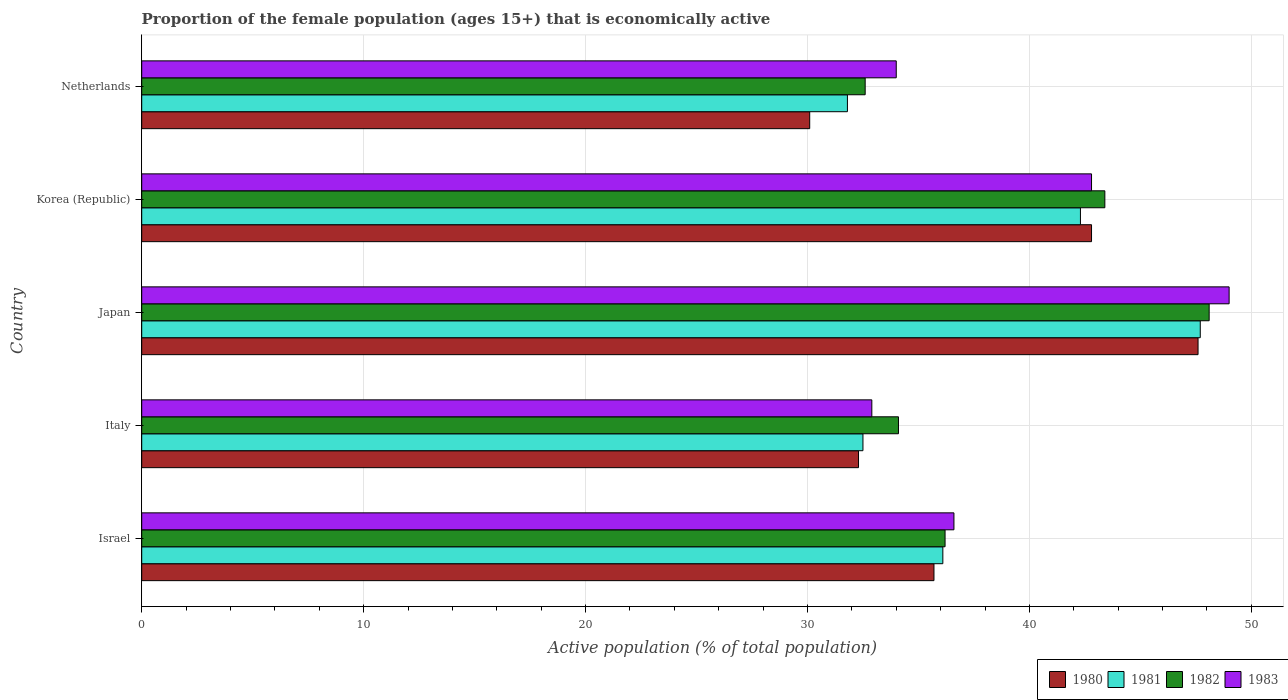How many groups of bars are there?
Make the answer very short. 5. Are the number of bars on each tick of the Y-axis equal?
Give a very brief answer. Yes. How many bars are there on the 5th tick from the top?
Provide a short and direct response. 4. What is the label of the 1st group of bars from the top?
Your answer should be compact. Netherlands. In how many cases, is the number of bars for a given country not equal to the number of legend labels?
Your answer should be very brief. 0. What is the proportion of the female population that is economically active in 1983 in Korea (Republic)?
Give a very brief answer. 42.8. Across all countries, what is the minimum proportion of the female population that is economically active in 1980?
Your answer should be very brief. 30.1. In which country was the proportion of the female population that is economically active in 1983 minimum?
Your response must be concise. Italy. What is the total proportion of the female population that is economically active in 1980 in the graph?
Offer a terse response. 188.5. What is the difference between the proportion of the female population that is economically active in 1983 in Korea (Republic) and that in Netherlands?
Offer a very short reply. 8.8. What is the average proportion of the female population that is economically active in 1980 per country?
Provide a succinct answer. 37.7. What is the difference between the proportion of the female population that is economically active in 1982 and proportion of the female population that is economically active in 1981 in Korea (Republic)?
Offer a terse response. 1.1. What is the ratio of the proportion of the female population that is economically active in 1982 in Italy to that in Netherlands?
Provide a succinct answer. 1.05. What is the difference between the highest and the second highest proportion of the female population that is economically active in 1980?
Your answer should be very brief. 4.8. What is the difference between the highest and the lowest proportion of the female population that is economically active in 1983?
Your response must be concise. 16.1. In how many countries, is the proportion of the female population that is economically active in 1982 greater than the average proportion of the female population that is economically active in 1982 taken over all countries?
Your answer should be compact. 2. What does the 3rd bar from the bottom in Italy represents?
Your response must be concise. 1982. Is it the case that in every country, the sum of the proportion of the female population that is economically active in 1980 and proportion of the female population that is economically active in 1981 is greater than the proportion of the female population that is economically active in 1982?
Your answer should be compact. Yes. Are all the bars in the graph horizontal?
Offer a terse response. Yes. How many countries are there in the graph?
Offer a terse response. 5. What is the difference between two consecutive major ticks on the X-axis?
Your response must be concise. 10. Are the values on the major ticks of X-axis written in scientific E-notation?
Your response must be concise. No. Does the graph contain any zero values?
Your answer should be very brief. No. Does the graph contain grids?
Give a very brief answer. Yes. How many legend labels are there?
Give a very brief answer. 4. How are the legend labels stacked?
Give a very brief answer. Horizontal. What is the title of the graph?
Your response must be concise. Proportion of the female population (ages 15+) that is economically active. Does "1993" appear as one of the legend labels in the graph?
Provide a short and direct response. No. What is the label or title of the X-axis?
Offer a terse response. Active population (% of total population). What is the label or title of the Y-axis?
Your response must be concise. Country. What is the Active population (% of total population) in 1980 in Israel?
Provide a succinct answer. 35.7. What is the Active population (% of total population) of 1981 in Israel?
Offer a very short reply. 36.1. What is the Active population (% of total population) of 1982 in Israel?
Your response must be concise. 36.2. What is the Active population (% of total population) in 1983 in Israel?
Your answer should be very brief. 36.6. What is the Active population (% of total population) in 1980 in Italy?
Keep it short and to the point. 32.3. What is the Active population (% of total population) of 1981 in Italy?
Provide a succinct answer. 32.5. What is the Active population (% of total population) of 1982 in Italy?
Your answer should be very brief. 34.1. What is the Active population (% of total population) of 1983 in Italy?
Your answer should be very brief. 32.9. What is the Active population (% of total population) of 1980 in Japan?
Your answer should be very brief. 47.6. What is the Active population (% of total population) of 1981 in Japan?
Offer a very short reply. 47.7. What is the Active population (% of total population) of 1982 in Japan?
Your answer should be very brief. 48.1. What is the Active population (% of total population) in 1980 in Korea (Republic)?
Give a very brief answer. 42.8. What is the Active population (% of total population) of 1981 in Korea (Republic)?
Provide a succinct answer. 42.3. What is the Active population (% of total population) of 1982 in Korea (Republic)?
Offer a very short reply. 43.4. What is the Active population (% of total population) in 1983 in Korea (Republic)?
Your answer should be compact. 42.8. What is the Active population (% of total population) of 1980 in Netherlands?
Make the answer very short. 30.1. What is the Active population (% of total population) of 1981 in Netherlands?
Provide a short and direct response. 31.8. What is the Active population (% of total population) in 1982 in Netherlands?
Give a very brief answer. 32.6. What is the Active population (% of total population) in 1983 in Netherlands?
Your answer should be very brief. 34. Across all countries, what is the maximum Active population (% of total population) in 1980?
Offer a very short reply. 47.6. Across all countries, what is the maximum Active population (% of total population) of 1981?
Give a very brief answer. 47.7. Across all countries, what is the maximum Active population (% of total population) of 1982?
Make the answer very short. 48.1. Across all countries, what is the maximum Active population (% of total population) of 1983?
Make the answer very short. 49. Across all countries, what is the minimum Active population (% of total population) in 1980?
Keep it short and to the point. 30.1. Across all countries, what is the minimum Active population (% of total population) in 1981?
Your response must be concise. 31.8. Across all countries, what is the minimum Active population (% of total population) of 1982?
Your answer should be very brief. 32.6. Across all countries, what is the minimum Active population (% of total population) of 1983?
Offer a very short reply. 32.9. What is the total Active population (% of total population) of 1980 in the graph?
Your answer should be very brief. 188.5. What is the total Active population (% of total population) of 1981 in the graph?
Ensure brevity in your answer.  190.4. What is the total Active population (% of total population) in 1982 in the graph?
Provide a short and direct response. 194.4. What is the total Active population (% of total population) of 1983 in the graph?
Provide a succinct answer. 195.3. What is the difference between the Active population (% of total population) in 1981 in Israel and that in Italy?
Your answer should be compact. 3.6. What is the difference between the Active population (% of total population) in 1982 in Israel and that in Italy?
Give a very brief answer. 2.1. What is the difference between the Active population (% of total population) in 1981 in Israel and that in Japan?
Offer a terse response. -11.6. What is the difference between the Active population (% of total population) of 1982 in Israel and that in Japan?
Ensure brevity in your answer.  -11.9. What is the difference between the Active population (% of total population) in 1980 in Israel and that in Korea (Republic)?
Offer a very short reply. -7.1. What is the difference between the Active population (% of total population) in 1980 in Israel and that in Netherlands?
Give a very brief answer. 5.6. What is the difference between the Active population (% of total population) of 1981 in Israel and that in Netherlands?
Your response must be concise. 4.3. What is the difference between the Active population (% of total population) in 1980 in Italy and that in Japan?
Provide a short and direct response. -15.3. What is the difference between the Active population (% of total population) of 1981 in Italy and that in Japan?
Your response must be concise. -15.2. What is the difference between the Active population (% of total population) in 1982 in Italy and that in Japan?
Your answer should be compact. -14. What is the difference between the Active population (% of total population) of 1983 in Italy and that in Japan?
Offer a terse response. -16.1. What is the difference between the Active population (% of total population) of 1981 in Italy and that in Korea (Republic)?
Offer a very short reply. -9.8. What is the difference between the Active population (% of total population) in 1980 in Italy and that in Netherlands?
Offer a very short reply. 2.2. What is the difference between the Active population (% of total population) of 1981 in Italy and that in Netherlands?
Offer a very short reply. 0.7. What is the difference between the Active population (% of total population) in 1982 in Italy and that in Netherlands?
Ensure brevity in your answer.  1.5. What is the difference between the Active population (% of total population) in 1983 in Italy and that in Netherlands?
Offer a very short reply. -1.1. What is the difference between the Active population (% of total population) in 1980 in Japan and that in Korea (Republic)?
Your response must be concise. 4.8. What is the difference between the Active population (% of total population) in 1981 in Japan and that in Korea (Republic)?
Your answer should be very brief. 5.4. What is the difference between the Active population (% of total population) in 1982 in Japan and that in Korea (Republic)?
Provide a succinct answer. 4.7. What is the difference between the Active population (% of total population) in 1983 in Japan and that in Korea (Republic)?
Give a very brief answer. 6.2. What is the difference between the Active population (% of total population) in 1980 in Japan and that in Netherlands?
Ensure brevity in your answer.  17.5. What is the difference between the Active population (% of total population) of 1981 in Japan and that in Netherlands?
Offer a very short reply. 15.9. What is the difference between the Active population (% of total population) of 1981 in Korea (Republic) and that in Netherlands?
Keep it short and to the point. 10.5. What is the difference between the Active population (% of total population) of 1983 in Korea (Republic) and that in Netherlands?
Provide a short and direct response. 8.8. What is the difference between the Active population (% of total population) in 1980 in Israel and the Active population (% of total population) in 1981 in Italy?
Your answer should be compact. 3.2. What is the difference between the Active population (% of total population) of 1980 in Israel and the Active population (% of total population) of 1982 in Italy?
Your answer should be compact. 1.6. What is the difference between the Active population (% of total population) in 1980 in Israel and the Active population (% of total population) in 1983 in Italy?
Give a very brief answer. 2.8. What is the difference between the Active population (% of total population) of 1981 in Israel and the Active population (% of total population) of 1982 in Italy?
Your answer should be compact. 2. What is the difference between the Active population (% of total population) of 1980 in Israel and the Active population (% of total population) of 1982 in Japan?
Your answer should be very brief. -12.4. What is the difference between the Active population (% of total population) in 1980 in Israel and the Active population (% of total population) in 1983 in Japan?
Your answer should be very brief. -13.3. What is the difference between the Active population (% of total population) of 1981 in Israel and the Active population (% of total population) of 1983 in Japan?
Your response must be concise. -12.9. What is the difference between the Active population (% of total population) in 1980 in Israel and the Active population (% of total population) in 1982 in Korea (Republic)?
Give a very brief answer. -7.7. What is the difference between the Active population (% of total population) of 1980 in Israel and the Active population (% of total population) of 1983 in Korea (Republic)?
Your response must be concise. -7.1. What is the difference between the Active population (% of total population) of 1981 in Israel and the Active population (% of total population) of 1982 in Korea (Republic)?
Provide a short and direct response. -7.3. What is the difference between the Active population (% of total population) in 1981 in Israel and the Active population (% of total population) in 1983 in Korea (Republic)?
Provide a succinct answer. -6.7. What is the difference between the Active population (% of total population) of 1980 in Israel and the Active population (% of total population) of 1981 in Netherlands?
Your answer should be compact. 3.9. What is the difference between the Active population (% of total population) in 1980 in Israel and the Active population (% of total population) in 1983 in Netherlands?
Make the answer very short. 1.7. What is the difference between the Active population (% of total population) of 1981 in Israel and the Active population (% of total population) of 1983 in Netherlands?
Offer a terse response. 2.1. What is the difference between the Active population (% of total population) of 1980 in Italy and the Active population (% of total population) of 1981 in Japan?
Ensure brevity in your answer.  -15.4. What is the difference between the Active population (% of total population) in 1980 in Italy and the Active population (% of total population) in 1982 in Japan?
Give a very brief answer. -15.8. What is the difference between the Active population (% of total population) in 1980 in Italy and the Active population (% of total population) in 1983 in Japan?
Offer a terse response. -16.7. What is the difference between the Active population (% of total population) in 1981 in Italy and the Active population (% of total population) in 1982 in Japan?
Give a very brief answer. -15.6. What is the difference between the Active population (% of total population) of 1981 in Italy and the Active population (% of total population) of 1983 in Japan?
Ensure brevity in your answer.  -16.5. What is the difference between the Active population (% of total population) in 1982 in Italy and the Active population (% of total population) in 1983 in Japan?
Your answer should be very brief. -14.9. What is the difference between the Active population (% of total population) in 1980 in Italy and the Active population (% of total population) in 1981 in Korea (Republic)?
Make the answer very short. -10. What is the difference between the Active population (% of total population) of 1980 in Italy and the Active population (% of total population) of 1982 in Korea (Republic)?
Ensure brevity in your answer.  -11.1. What is the difference between the Active population (% of total population) in 1980 in Italy and the Active population (% of total population) in 1983 in Korea (Republic)?
Your response must be concise. -10.5. What is the difference between the Active population (% of total population) in 1981 in Italy and the Active population (% of total population) in 1982 in Korea (Republic)?
Ensure brevity in your answer.  -10.9. What is the difference between the Active population (% of total population) of 1980 in Italy and the Active population (% of total population) of 1981 in Netherlands?
Provide a short and direct response. 0.5. What is the difference between the Active population (% of total population) in 1980 in Italy and the Active population (% of total population) in 1982 in Netherlands?
Offer a very short reply. -0.3. What is the difference between the Active population (% of total population) in 1981 in Italy and the Active population (% of total population) in 1982 in Netherlands?
Offer a terse response. -0.1. What is the difference between the Active population (% of total population) in 1980 in Japan and the Active population (% of total population) in 1981 in Korea (Republic)?
Offer a very short reply. 5.3. What is the difference between the Active population (% of total population) of 1980 in Japan and the Active population (% of total population) of 1982 in Korea (Republic)?
Give a very brief answer. 4.2. What is the difference between the Active population (% of total population) of 1980 in Japan and the Active population (% of total population) of 1983 in Korea (Republic)?
Provide a succinct answer. 4.8. What is the difference between the Active population (% of total population) of 1981 in Japan and the Active population (% of total population) of 1982 in Korea (Republic)?
Your answer should be very brief. 4.3. What is the difference between the Active population (% of total population) of 1981 in Japan and the Active population (% of total population) of 1983 in Korea (Republic)?
Provide a succinct answer. 4.9. What is the difference between the Active population (% of total population) in 1980 in Japan and the Active population (% of total population) in 1981 in Netherlands?
Offer a very short reply. 15.8. What is the difference between the Active population (% of total population) in 1981 in Japan and the Active population (% of total population) in 1982 in Netherlands?
Your answer should be compact. 15.1. What is the difference between the Active population (% of total population) of 1981 in Japan and the Active population (% of total population) of 1983 in Netherlands?
Ensure brevity in your answer.  13.7. What is the difference between the Active population (% of total population) of 1980 in Korea (Republic) and the Active population (% of total population) of 1981 in Netherlands?
Give a very brief answer. 11. What is the difference between the Active population (% of total population) of 1980 in Korea (Republic) and the Active population (% of total population) of 1982 in Netherlands?
Offer a terse response. 10.2. What is the difference between the Active population (% of total population) of 1981 in Korea (Republic) and the Active population (% of total population) of 1983 in Netherlands?
Keep it short and to the point. 8.3. What is the difference between the Active population (% of total population) in 1982 in Korea (Republic) and the Active population (% of total population) in 1983 in Netherlands?
Your answer should be compact. 9.4. What is the average Active population (% of total population) of 1980 per country?
Your answer should be compact. 37.7. What is the average Active population (% of total population) of 1981 per country?
Make the answer very short. 38.08. What is the average Active population (% of total population) of 1982 per country?
Provide a succinct answer. 38.88. What is the average Active population (% of total population) in 1983 per country?
Keep it short and to the point. 39.06. What is the difference between the Active population (% of total population) of 1980 and Active population (% of total population) of 1981 in Israel?
Ensure brevity in your answer.  -0.4. What is the difference between the Active population (% of total population) in 1980 and Active population (% of total population) in 1983 in Israel?
Keep it short and to the point. -0.9. What is the difference between the Active population (% of total population) of 1982 and Active population (% of total population) of 1983 in Israel?
Provide a succinct answer. -0.4. What is the difference between the Active population (% of total population) of 1980 and Active population (% of total population) of 1981 in Italy?
Give a very brief answer. -0.2. What is the difference between the Active population (% of total population) of 1981 and Active population (% of total population) of 1982 in Italy?
Offer a terse response. -1.6. What is the difference between the Active population (% of total population) in 1981 and Active population (% of total population) in 1983 in Italy?
Your answer should be very brief. -0.4. What is the difference between the Active population (% of total population) in 1980 and Active population (% of total population) in 1982 in Japan?
Your response must be concise. -0.5. What is the difference between the Active population (% of total population) of 1980 and Active population (% of total population) of 1983 in Japan?
Your answer should be very brief. -1.4. What is the difference between the Active population (% of total population) of 1981 and Active population (% of total population) of 1983 in Japan?
Your answer should be very brief. -1.3. What is the difference between the Active population (% of total population) in 1982 and Active population (% of total population) in 1983 in Japan?
Ensure brevity in your answer.  -0.9. What is the difference between the Active population (% of total population) in 1980 and Active population (% of total population) in 1981 in Korea (Republic)?
Offer a terse response. 0.5. What is the difference between the Active population (% of total population) of 1980 and Active population (% of total population) of 1983 in Korea (Republic)?
Provide a succinct answer. 0. What is the difference between the Active population (% of total population) of 1981 and Active population (% of total population) of 1982 in Korea (Republic)?
Ensure brevity in your answer.  -1.1. What is the difference between the Active population (% of total population) of 1981 and Active population (% of total population) of 1983 in Korea (Republic)?
Make the answer very short. -0.5. What is the difference between the Active population (% of total population) of 1982 and Active population (% of total population) of 1983 in Korea (Republic)?
Your answer should be compact. 0.6. What is the ratio of the Active population (% of total population) of 1980 in Israel to that in Italy?
Keep it short and to the point. 1.11. What is the ratio of the Active population (% of total population) of 1981 in Israel to that in Italy?
Ensure brevity in your answer.  1.11. What is the ratio of the Active population (% of total population) in 1982 in Israel to that in Italy?
Give a very brief answer. 1.06. What is the ratio of the Active population (% of total population) in 1983 in Israel to that in Italy?
Ensure brevity in your answer.  1.11. What is the ratio of the Active population (% of total population) in 1981 in Israel to that in Japan?
Your answer should be compact. 0.76. What is the ratio of the Active population (% of total population) of 1982 in Israel to that in Japan?
Your response must be concise. 0.75. What is the ratio of the Active population (% of total population) of 1983 in Israel to that in Japan?
Provide a succinct answer. 0.75. What is the ratio of the Active population (% of total population) of 1980 in Israel to that in Korea (Republic)?
Your response must be concise. 0.83. What is the ratio of the Active population (% of total population) of 1981 in Israel to that in Korea (Republic)?
Ensure brevity in your answer.  0.85. What is the ratio of the Active population (% of total population) of 1982 in Israel to that in Korea (Republic)?
Make the answer very short. 0.83. What is the ratio of the Active population (% of total population) of 1983 in Israel to that in Korea (Republic)?
Keep it short and to the point. 0.86. What is the ratio of the Active population (% of total population) of 1980 in Israel to that in Netherlands?
Keep it short and to the point. 1.19. What is the ratio of the Active population (% of total population) in 1981 in Israel to that in Netherlands?
Keep it short and to the point. 1.14. What is the ratio of the Active population (% of total population) of 1982 in Israel to that in Netherlands?
Your answer should be very brief. 1.11. What is the ratio of the Active population (% of total population) in 1983 in Israel to that in Netherlands?
Ensure brevity in your answer.  1.08. What is the ratio of the Active population (% of total population) in 1980 in Italy to that in Japan?
Offer a terse response. 0.68. What is the ratio of the Active population (% of total population) in 1981 in Italy to that in Japan?
Make the answer very short. 0.68. What is the ratio of the Active population (% of total population) in 1982 in Italy to that in Japan?
Offer a very short reply. 0.71. What is the ratio of the Active population (% of total population) in 1983 in Italy to that in Japan?
Ensure brevity in your answer.  0.67. What is the ratio of the Active population (% of total population) of 1980 in Italy to that in Korea (Republic)?
Ensure brevity in your answer.  0.75. What is the ratio of the Active population (% of total population) in 1981 in Italy to that in Korea (Republic)?
Provide a succinct answer. 0.77. What is the ratio of the Active population (% of total population) in 1982 in Italy to that in Korea (Republic)?
Ensure brevity in your answer.  0.79. What is the ratio of the Active population (% of total population) in 1983 in Italy to that in Korea (Republic)?
Provide a short and direct response. 0.77. What is the ratio of the Active population (% of total population) in 1980 in Italy to that in Netherlands?
Keep it short and to the point. 1.07. What is the ratio of the Active population (% of total population) of 1982 in Italy to that in Netherlands?
Your answer should be compact. 1.05. What is the ratio of the Active population (% of total population) of 1983 in Italy to that in Netherlands?
Make the answer very short. 0.97. What is the ratio of the Active population (% of total population) of 1980 in Japan to that in Korea (Republic)?
Give a very brief answer. 1.11. What is the ratio of the Active population (% of total population) in 1981 in Japan to that in Korea (Republic)?
Your answer should be very brief. 1.13. What is the ratio of the Active population (% of total population) of 1982 in Japan to that in Korea (Republic)?
Keep it short and to the point. 1.11. What is the ratio of the Active population (% of total population) of 1983 in Japan to that in Korea (Republic)?
Ensure brevity in your answer.  1.14. What is the ratio of the Active population (% of total population) of 1980 in Japan to that in Netherlands?
Provide a short and direct response. 1.58. What is the ratio of the Active population (% of total population) in 1981 in Japan to that in Netherlands?
Offer a very short reply. 1.5. What is the ratio of the Active population (% of total population) in 1982 in Japan to that in Netherlands?
Provide a short and direct response. 1.48. What is the ratio of the Active population (% of total population) of 1983 in Japan to that in Netherlands?
Your response must be concise. 1.44. What is the ratio of the Active population (% of total population) of 1980 in Korea (Republic) to that in Netherlands?
Ensure brevity in your answer.  1.42. What is the ratio of the Active population (% of total population) of 1981 in Korea (Republic) to that in Netherlands?
Make the answer very short. 1.33. What is the ratio of the Active population (% of total population) of 1982 in Korea (Republic) to that in Netherlands?
Provide a short and direct response. 1.33. What is the ratio of the Active population (% of total population) of 1983 in Korea (Republic) to that in Netherlands?
Ensure brevity in your answer.  1.26. What is the difference between the highest and the second highest Active population (% of total population) of 1980?
Ensure brevity in your answer.  4.8. What is the difference between the highest and the second highest Active population (% of total population) in 1981?
Ensure brevity in your answer.  5.4. What is the difference between the highest and the second highest Active population (% of total population) of 1982?
Your answer should be very brief. 4.7. What is the difference between the highest and the lowest Active population (% of total population) in 1982?
Your answer should be very brief. 15.5. What is the difference between the highest and the lowest Active population (% of total population) of 1983?
Offer a terse response. 16.1. 